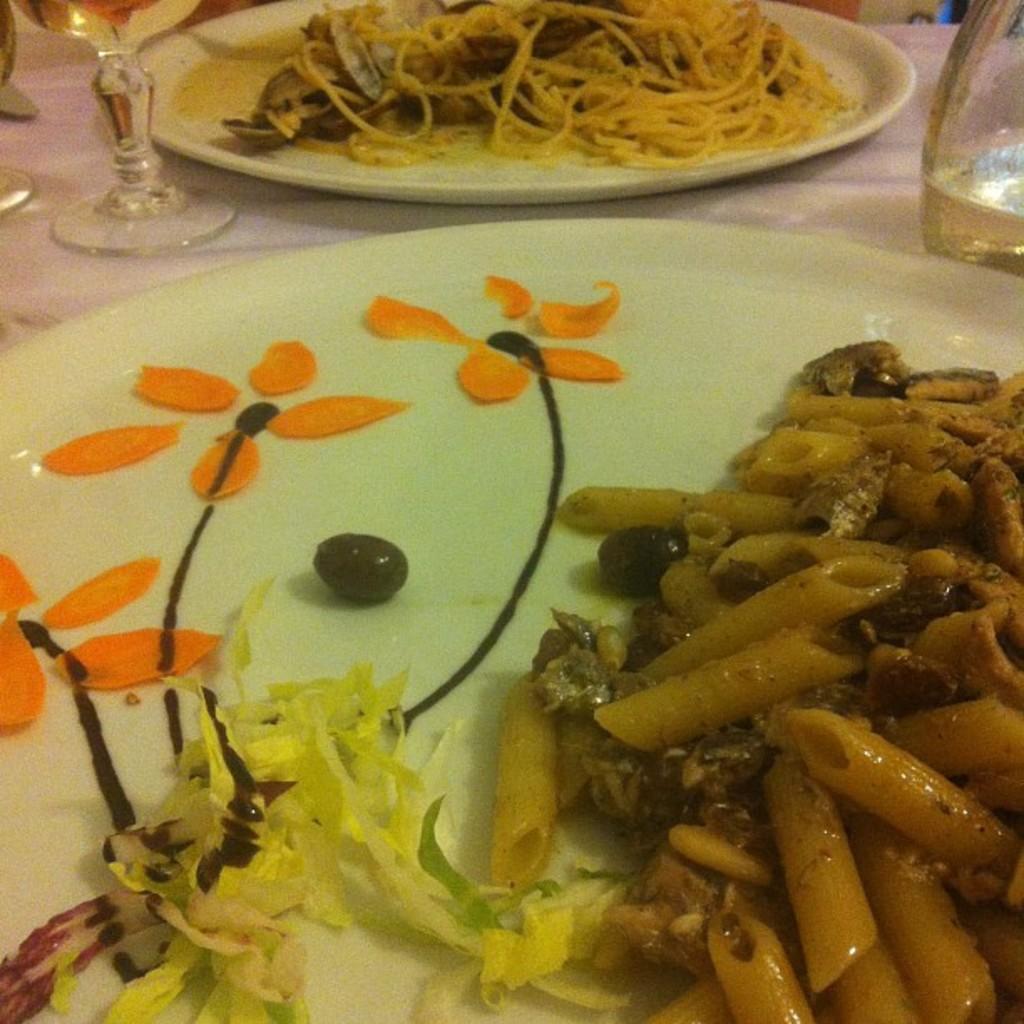In one or two sentences, can you explain what this image depicts? In this picture, we see a table which is covered with a white sheet. We see a plate containing pasta, a plate containing noodles and a glass containing liquid are placed on the table. 